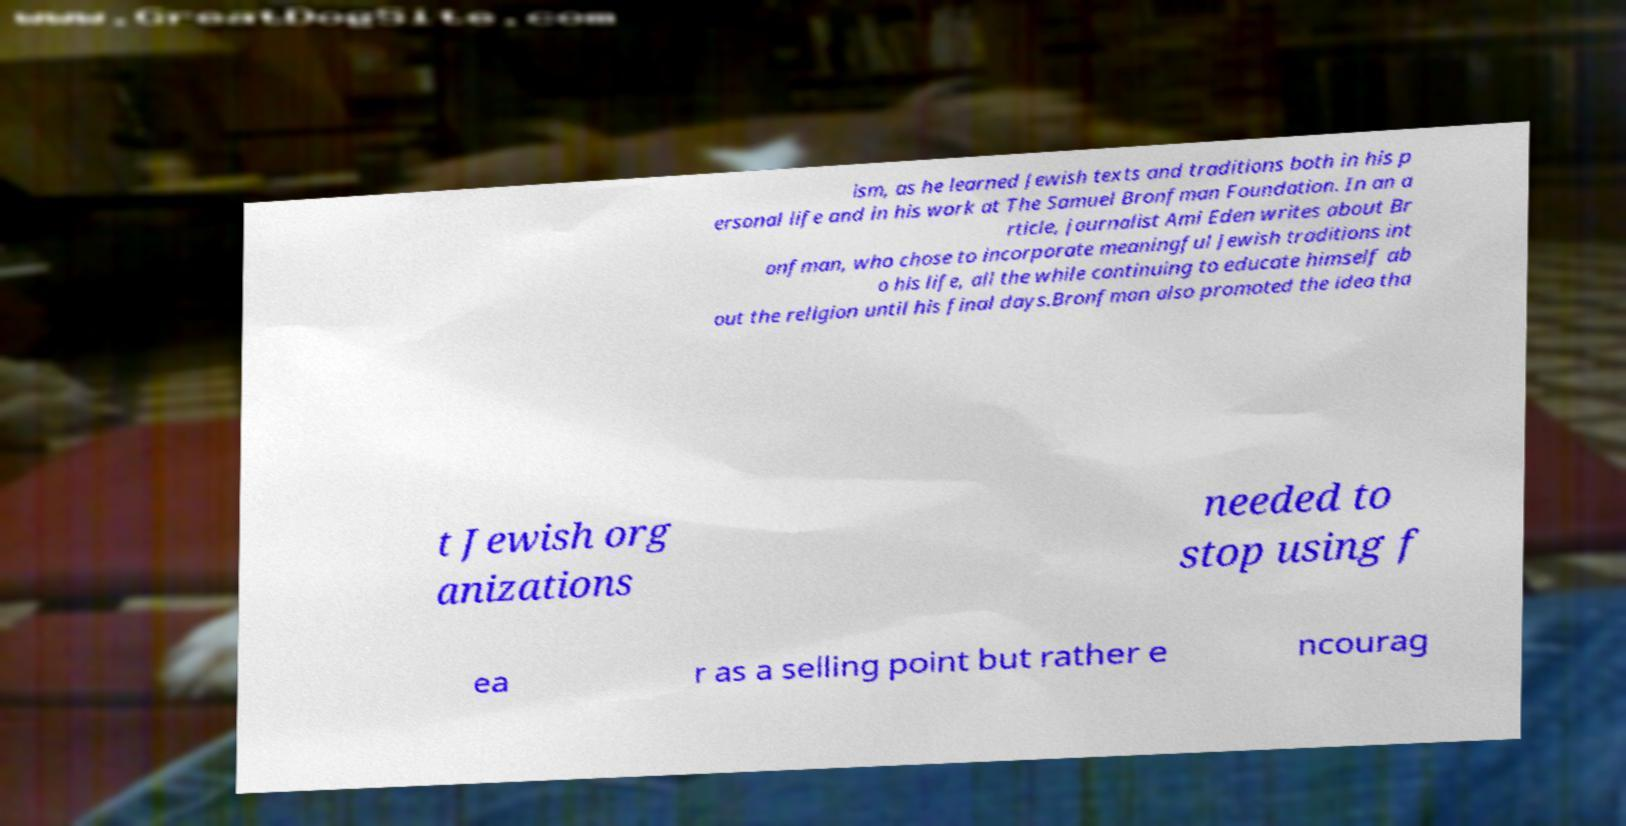What messages or text are displayed in this image? I need them in a readable, typed format. ism, as he learned Jewish texts and traditions both in his p ersonal life and in his work at The Samuel Bronfman Foundation. In an a rticle, journalist Ami Eden writes about Br onfman, who chose to incorporate meaningful Jewish traditions int o his life, all the while continuing to educate himself ab out the religion until his final days.Bronfman also promoted the idea tha t Jewish org anizations needed to stop using f ea r as a selling point but rather e ncourag 